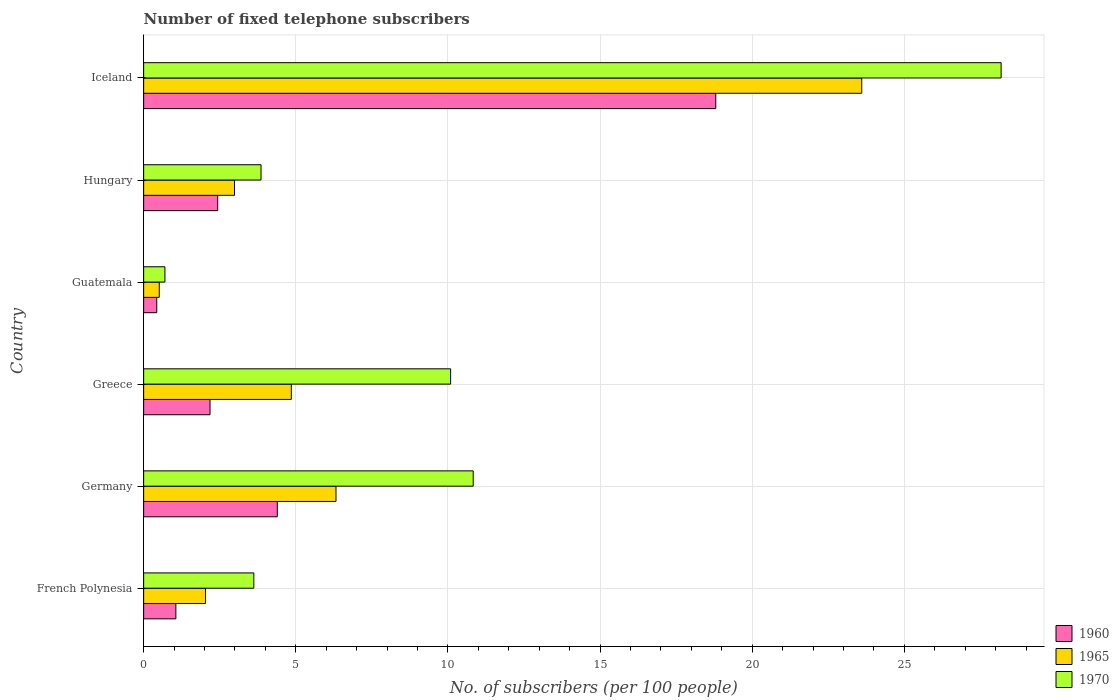Are the number of bars per tick equal to the number of legend labels?
Your answer should be very brief. Yes. Are the number of bars on each tick of the Y-axis equal?
Keep it short and to the point. Yes. What is the label of the 2nd group of bars from the top?
Your answer should be compact. Hungary. What is the number of fixed telephone subscribers in 1965 in Germany?
Your answer should be very brief. 6.32. Across all countries, what is the maximum number of fixed telephone subscribers in 1970?
Your answer should be compact. 28.18. Across all countries, what is the minimum number of fixed telephone subscribers in 1960?
Your response must be concise. 0.43. In which country was the number of fixed telephone subscribers in 1965 maximum?
Provide a succinct answer. Iceland. In which country was the number of fixed telephone subscribers in 1970 minimum?
Your response must be concise. Guatemala. What is the total number of fixed telephone subscribers in 1960 in the graph?
Ensure brevity in your answer.  29.3. What is the difference between the number of fixed telephone subscribers in 1960 in Germany and that in Iceland?
Provide a short and direct response. -14.41. What is the difference between the number of fixed telephone subscribers in 1970 in Greece and the number of fixed telephone subscribers in 1965 in Hungary?
Offer a terse response. 7.1. What is the average number of fixed telephone subscribers in 1960 per country?
Provide a short and direct response. 4.88. What is the difference between the number of fixed telephone subscribers in 1970 and number of fixed telephone subscribers in 1960 in Germany?
Offer a terse response. 6.44. In how many countries, is the number of fixed telephone subscribers in 1965 greater than 6 ?
Provide a succinct answer. 2. What is the ratio of the number of fixed telephone subscribers in 1970 in Greece to that in Hungary?
Your answer should be very brief. 2.62. What is the difference between the highest and the second highest number of fixed telephone subscribers in 1960?
Provide a short and direct response. 14.41. What is the difference between the highest and the lowest number of fixed telephone subscribers in 1970?
Make the answer very short. 27.48. In how many countries, is the number of fixed telephone subscribers in 1960 greater than the average number of fixed telephone subscribers in 1960 taken over all countries?
Offer a very short reply. 1. Is the sum of the number of fixed telephone subscribers in 1965 in Greece and Guatemala greater than the maximum number of fixed telephone subscribers in 1960 across all countries?
Your response must be concise. No. What does the 2nd bar from the bottom in Hungary represents?
Offer a very short reply. 1965. How many bars are there?
Provide a short and direct response. 18. Are all the bars in the graph horizontal?
Ensure brevity in your answer.  Yes. How many countries are there in the graph?
Ensure brevity in your answer.  6. Are the values on the major ticks of X-axis written in scientific E-notation?
Your answer should be very brief. No. Where does the legend appear in the graph?
Provide a short and direct response. Bottom right. How many legend labels are there?
Your answer should be very brief. 3. How are the legend labels stacked?
Your response must be concise. Vertical. What is the title of the graph?
Offer a very short reply. Number of fixed telephone subscribers. What is the label or title of the X-axis?
Your answer should be very brief. No. of subscribers (per 100 people). What is the No. of subscribers (per 100 people) of 1960 in French Polynesia?
Your answer should be very brief. 1.06. What is the No. of subscribers (per 100 people) of 1965 in French Polynesia?
Ensure brevity in your answer.  2.03. What is the No. of subscribers (per 100 people) in 1970 in French Polynesia?
Ensure brevity in your answer.  3.62. What is the No. of subscribers (per 100 people) in 1960 in Germany?
Make the answer very short. 4.39. What is the No. of subscribers (per 100 people) in 1965 in Germany?
Your response must be concise. 6.32. What is the No. of subscribers (per 100 people) of 1970 in Germany?
Make the answer very short. 10.83. What is the No. of subscribers (per 100 people) in 1960 in Greece?
Offer a very short reply. 2.18. What is the No. of subscribers (per 100 people) in 1965 in Greece?
Provide a succinct answer. 4.85. What is the No. of subscribers (per 100 people) of 1970 in Greece?
Offer a terse response. 10.09. What is the No. of subscribers (per 100 people) of 1960 in Guatemala?
Your response must be concise. 0.43. What is the No. of subscribers (per 100 people) in 1965 in Guatemala?
Keep it short and to the point. 0.51. What is the No. of subscribers (per 100 people) in 1970 in Guatemala?
Keep it short and to the point. 0.7. What is the No. of subscribers (per 100 people) in 1960 in Hungary?
Ensure brevity in your answer.  2.43. What is the No. of subscribers (per 100 people) of 1965 in Hungary?
Give a very brief answer. 2.99. What is the No. of subscribers (per 100 people) in 1970 in Hungary?
Keep it short and to the point. 3.86. What is the No. of subscribers (per 100 people) in 1960 in Iceland?
Provide a short and direct response. 18.8. What is the No. of subscribers (per 100 people) of 1965 in Iceland?
Your answer should be very brief. 23.6. What is the No. of subscribers (per 100 people) in 1970 in Iceland?
Offer a terse response. 28.18. Across all countries, what is the maximum No. of subscribers (per 100 people) of 1960?
Provide a short and direct response. 18.8. Across all countries, what is the maximum No. of subscribers (per 100 people) of 1965?
Provide a succinct answer. 23.6. Across all countries, what is the maximum No. of subscribers (per 100 people) in 1970?
Keep it short and to the point. 28.18. Across all countries, what is the minimum No. of subscribers (per 100 people) in 1960?
Give a very brief answer. 0.43. Across all countries, what is the minimum No. of subscribers (per 100 people) of 1965?
Provide a succinct answer. 0.51. Across all countries, what is the minimum No. of subscribers (per 100 people) in 1970?
Provide a succinct answer. 0.7. What is the total No. of subscribers (per 100 people) in 1960 in the graph?
Give a very brief answer. 29.3. What is the total No. of subscribers (per 100 people) in 1965 in the graph?
Your response must be concise. 40.3. What is the total No. of subscribers (per 100 people) of 1970 in the graph?
Provide a short and direct response. 57.27. What is the difference between the No. of subscribers (per 100 people) of 1960 in French Polynesia and that in Germany?
Ensure brevity in your answer.  -3.33. What is the difference between the No. of subscribers (per 100 people) of 1965 in French Polynesia and that in Germany?
Your answer should be very brief. -4.29. What is the difference between the No. of subscribers (per 100 people) of 1970 in French Polynesia and that in Germany?
Offer a very short reply. -7.21. What is the difference between the No. of subscribers (per 100 people) in 1960 in French Polynesia and that in Greece?
Your answer should be very brief. -1.12. What is the difference between the No. of subscribers (per 100 people) of 1965 in French Polynesia and that in Greece?
Offer a very short reply. -2.82. What is the difference between the No. of subscribers (per 100 people) of 1970 in French Polynesia and that in Greece?
Your answer should be very brief. -6.47. What is the difference between the No. of subscribers (per 100 people) in 1960 in French Polynesia and that in Guatemala?
Keep it short and to the point. 0.63. What is the difference between the No. of subscribers (per 100 people) in 1965 in French Polynesia and that in Guatemala?
Offer a very short reply. 1.52. What is the difference between the No. of subscribers (per 100 people) in 1970 in French Polynesia and that in Guatemala?
Ensure brevity in your answer.  2.92. What is the difference between the No. of subscribers (per 100 people) in 1960 in French Polynesia and that in Hungary?
Ensure brevity in your answer.  -1.37. What is the difference between the No. of subscribers (per 100 people) in 1965 in French Polynesia and that in Hungary?
Provide a succinct answer. -0.95. What is the difference between the No. of subscribers (per 100 people) of 1970 in French Polynesia and that in Hungary?
Offer a very short reply. -0.24. What is the difference between the No. of subscribers (per 100 people) of 1960 in French Polynesia and that in Iceland?
Offer a very short reply. -17.74. What is the difference between the No. of subscribers (per 100 people) of 1965 in French Polynesia and that in Iceland?
Offer a terse response. -21.56. What is the difference between the No. of subscribers (per 100 people) in 1970 in French Polynesia and that in Iceland?
Your answer should be very brief. -24.56. What is the difference between the No. of subscribers (per 100 people) of 1960 in Germany and that in Greece?
Ensure brevity in your answer.  2.21. What is the difference between the No. of subscribers (per 100 people) of 1965 in Germany and that in Greece?
Give a very brief answer. 1.47. What is the difference between the No. of subscribers (per 100 people) in 1970 in Germany and that in Greece?
Keep it short and to the point. 0.74. What is the difference between the No. of subscribers (per 100 people) of 1960 in Germany and that in Guatemala?
Make the answer very short. 3.96. What is the difference between the No. of subscribers (per 100 people) of 1965 in Germany and that in Guatemala?
Offer a very short reply. 5.81. What is the difference between the No. of subscribers (per 100 people) in 1970 in Germany and that in Guatemala?
Ensure brevity in your answer.  10.13. What is the difference between the No. of subscribers (per 100 people) of 1960 in Germany and that in Hungary?
Offer a very short reply. 1.96. What is the difference between the No. of subscribers (per 100 people) in 1965 in Germany and that in Hungary?
Your answer should be very brief. 3.33. What is the difference between the No. of subscribers (per 100 people) of 1970 in Germany and that in Hungary?
Provide a succinct answer. 6.97. What is the difference between the No. of subscribers (per 100 people) of 1960 in Germany and that in Iceland?
Ensure brevity in your answer.  -14.41. What is the difference between the No. of subscribers (per 100 people) of 1965 in Germany and that in Iceland?
Provide a succinct answer. -17.28. What is the difference between the No. of subscribers (per 100 people) in 1970 in Germany and that in Iceland?
Your answer should be very brief. -17.35. What is the difference between the No. of subscribers (per 100 people) of 1960 in Greece and that in Guatemala?
Offer a very short reply. 1.75. What is the difference between the No. of subscribers (per 100 people) in 1965 in Greece and that in Guatemala?
Give a very brief answer. 4.34. What is the difference between the No. of subscribers (per 100 people) in 1970 in Greece and that in Guatemala?
Make the answer very short. 9.39. What is the difference between the No. of subscribers (per 100 people) in 1960 in Greece and that in Hungary?
Offer a very short reply. -0.25. What is the difference between the No. of subscribers (per 100 people) in 1965 in Greece and that in Hungary?
Your answer should be very brief. 1.87. What is the difference between the No. of subscribers (per 100 people) of 1970 in Greece and that in Hungary?
Provide a short and direct response. 6.23. What is the difference between the No. of subscribers (per 100 people) of 1960 in Greece and that in Iceland?
Provide a succinct answer. -16.62. What is the difference between the No. of subscribers (per 100 people) of 1965 in Greece and that in Iceland?
Make the answer very short. -18.74. What is the difference between the No. of subscribers (per 100 people) in 1970 in Greece and that in Iceland?
Give a very brief answer. -18.09. What is the difference between the No. of subscribers (per 100 people) of 1960 in Guatemala and that in Hungary?
Make the answer very short. -2. What is the difference between the No. of subscribers (per 100 people) of 1965 in Guatemala and that in Hungary?
Your response must be concise. -2.47. What is the difference between the No. of subscribers (per 100 people) of 1970 in Guatemala and that in Hungary?
Offer a very short reply. -3.16. What is the difference between the No. of subscribers (per 100 people) of 1960 in Guatemala and that in Iceland?
Your answer should be compact. -18.37. What is the difference between the No. of subscribers (per 100 people) of 1965 in Guatemala and that in Iceland?
Keep it short and to the point. -23.08. What is the difference between the No. of subscribers (per 100 people) in 1970 in Guatemala and that in Iceland?
Your answer should be very brief. -27.48. What is the difference between the No. of subscribers (per 100 people) in 1960 in Hungary and that in Iceland?
Your response must be concise. -16.37. What is the difference between the No. of subscribers (per 100 people) of 1965 in Hungary and that in Iceland?
Provide a succinct answer. -20.61. What is the difference between the No. of subscribers (per 100 people) of 1970 in Hungary and that in Iceland?
Provide a succinct answer. -24.32. What is the difference between the No. of subscribers (per 100 people) of 1960 in French Polynesia and the No. of subscribers (per 100 people) of 1965 in Germany?
Your answer should be compact. -5.26. What is the difference between the No. of subscribers (per 100 people) in 1960 in French Polynesia and the No. of subscribers (per 100 people) in 1970 in Germany?
Your response must be concise. -9.77. What is the difference between the No. of subscribers (per 100 people) in 1965 in French Polynesia and the No. of subscribers (per 100 people) in 1970 in Germany?
Your response must be concise. -8.8. What is the difference between the No. of subscribers (per 100 people) of 1960 in French Polynesia and the No. of subscribers (per 100 people) of 1965 in Greece?
Provide a succinct answer. -3.79. What is the difference between the No. of subscribers (per 100 people) in 1960 in French Polynesia and the No. of subscribers (per 100 people) in 1970 in Greece?
Offer a terse response. -9.03. What is the difference between the No. of subscribers (per 100 people) of 1965 in French Polynesia and the No. of subscribers (per 100 people) of 1970 in Greece?
Offer a terse response. -8.05. What is the difference between the No. of subscribers (per 100 people) of 1960 in French Polynesia and the No. of subscribers (per 100 people) of 1965 in Guatemala?
Your response must be concise. 0.55. What is the difference between the No. of subscribers (per 100 people) of 1960 in French Polynesia and the No. of subscribers (per 100 people) of 1970 in Guatemala?
Give a very brief answer. 0.36. What is the difference between the No. of subscribers (per 100 people) of 1965 in French Polynesia and the No. of subscribers (per 100 people) of 1970 in Guatemala?
Provide a short and direct response. 1.33. What is the difference between the No. of subscribers (per 100 people) in 1960 in French Polynesia and the No. of subscribers (per 100 people) in 1965 in Hungary?
Your answer should be compact. -1.93. What is the difference between the No. of subscribers (per 100 people) of 1960 in French Polynesia and the No. of subscribers (per 100 people) of 1970 in Hungary?
Provide a short and direct response. -2.8. What is the difference between the No. of subscribers (per 100 people) in 1965 in French Polynesia and the No. of subscribers (per 100 people) in 1970 in Hungary?
Ensure brevity in your answer.  -1.82. What is the difference between the No. of subscribers (per 100 people) of 1960 in French Polynesia and the No. of subscribers (per 100 people) of 1965 in Iceland?
Make the answer very short. -22.54. What is the difference between the No. of subscribers (per 100 people) in 1960 in French Polynesia and the No. of subscribers (per 100 people) in 1970 in Iceland?
Your response must be concise. -27.12. What is the difference between the No. of subscribers (per 100 people) in 1965 in French Polynesia and the No. of subscribers (per 100 people) in 1970 in Iceland?
Keep it short and to the point. -26.14. What is the difference between the No. of subscribers (per 100 people) of 1960 in Germany and the No. of subscribers (per 100 people) of 1965 in Greece?
Your answer should be compact. -0.46. What is the difference between the No. of subscribers (per 100 people) in 1960 in Germany and the No. of subscribers (per 100 people) in 1970 in Greece?
Offer a very short reply. -5.7. What is the difference between the No. of subscribers (per 100 people) of 1965 in Germany and the No. of subscribers (per 100 people) of 1970 in Greece?
Make the answer very short. -3.77. What is the difference between the No. of subscribers (per 100 people) in 1960 in Germany and the No. of subscribers (per 100 people) in 1965 in Guatemala?
Provide a succinct answer. 3.88. What is the difference between the No. of subscribers (per 100 people) of 1960 in Germany and the No. of subscribers (per 100 people) of 1970 in Guatemala?
Provide a succinct answer. 3.69. What is the difference between the No. of subscribers (per 100 people) of 1965 in Germany and the No. of subscribers (per 100 people) of 1970 in Guatemala?
Your answer should be compact. 5.62. What is the difference between the No. of subscribers (per 100 people) of 1960 in Germany and the No. of subscribers (per 100 people) of 1965 in Hungary?
Keep it short and to the point. 1.41. What is the difference between the No. of subscribers (per 100 people) of 1960 in Germany and the No. of subscribers (per 100 people) of 1970 in Hungary?
Keep it short and to the point. 0.53. What is the difference between the No. of subscribers (per 100 people) in 1965 in Germany and the No. of subscribers (per 100 people) in 1970 in Hungary?
Make the answer very short. 2.46. What is the difference between the No. of subscribers (per 100 people) in 1960 in Germany and the No. of subscribers (per 100 people) in 1965 in Iceland?
Your response must be concise. -19.21. What is the difference between the No. of subscribers (per 100 people) in 1960 in Germany and the No. of subscribers (per 100 people) in 1970 in Iceland?
Give a very brief answer. -23.79. What is the difference between the No. of subscribers (per 100 people) of 1965 in Germany and the No. of subscribers (per 100 people) of 1970 in Iceland?
Give a very brief answer. -21.86. What is the difference between the No. of subscribers (per 100 people) of 1960 in Greece and the No. of subscribers (per 100 people) of 1965 in Guatemala?
Keep it short and to the point. 1.67. What is the difference between the No. of subscribers (per 100 people) in 1960 in Greece and the No. of subscribers (per 100 people) in 1970 in Guatemala?
Your answer should be very brief. 1.48. What is the difference between the No. of subscribers (per 100 people) of 1965 in Greece and the No. of subscribers (per 100 people) of 1970 in Guatemala?
Provide a succinct answer. 4.15. What is the difference between the No. of subscribers (per 100 people) of 1960 in Greece and the No. of subscribers (per 100 people) of 1965 in Hungary?
Provide a short and direct response. -0.81. What is the difference between the No. of subscribers (per 100 people) of 1960 in Greece and the No. of subscribers (per 100 people) of 1970 in Hungary?
Your answer should be compact. -1.68. What is the difference between the No. of subscribers (per 100 people) in 1960 in Greece and the No. of subscribers (per 100 people) in 1965 in Iceland?
Give a very brief answer. -21.42. What is the difference between the No. of subscribers (per 100 people) of 1960 in Greece and the No. of subscribers (per 100 people) of 1970 in Iceland?
Your answer should be compact. -26. What is the difference between the No. of subscribers (per 100 people) in 1965 in Greece and the No. of subscribers (per 100 people) in 1970 in Iceland?
Give a very brief answer. -23.32. What is the difference between the No. of subscribers (per 100 people) in 1960 in Guatemala and the No. of subscribers (per 100 people) in 1965 in Hungary?
Keep it short and to the point. -2.56. What is the difference between the No. of subscribers (per 100 people) of 1960 in Guatemala and the No. of subscribers (per 100 people) of 1970 in Hungary?
Provide a succinct answer. -3.43. What is the difference between the No. of subscribers (per 100 people) in 1965 in Guatemala and the No. of subscribers (per 100 people) in 1970 in Hungary?
Provide a short and direct response. -3.34. What is the difference between the No. of subscribers (per 100 people) in 1960 in Guatemala and the No. of subscribers (per 100 people) in 1965 in Iceland?
Your answer should be very brief. -23.17. What is the difference between the No. of subscribers (per 100 people) of 1960 in Guatemala and the No. of subscribers (per 100 people) of 1970 in Iceland?
Your answer should be very brief. -27.75. What is the difference between the No. of subscribers (per 100 people) in 1965 in Guatemala and the No. of subscribers (per 100 people) in 1970 in Iceland?
Your answer should be very brief. -27.66. What is the difference between the No. of subscribers (per 100 people) of 1960 in Hungary and the No. of subscribers (per 100 people) of 1965 in Iceland?
Offer a very short reply. -21.16. What is the difference between the No. of subscribers (per 100 people) of 1960 in Hungary and the No. of subscribers (per 100 people) of 1970 in Iceland?
Offer a terse response. -25.74. What is the difference between the No. of subscribers (per 100 people) of 1965 in Hungary and the No. of subscribers (per 100 people) of 1970 in Iceland?
Give a very brief answer. -25.19. What is the average No. of subscribers (per 100 people) in 1960 per country?
Your answer should be compact. 4.88. What is the average No. of subscribers (per 100 people) in 1965 per country?
Offer a very short reply. 6.72. What is the average No. of subscribers (per 100 people) of 1970 per country?
Make the answer very short. 9.55. What is the difference between the No. of subscribers (per 100 people) of 1960 and No. of subscribers (per 100 people) of 1965 in French Polynesia?
Ensure brevity in your answer.  -0.97. What is the difference between the No. of subscribers (per 100 people) in 1960 and No. of subscribers (per 100 people) in 1970 in French Polynesia?
Provide a short and direct response. -2.56. What is the difference between the No. of subscribers (per 100 people) in 1965 and No. of subscribers (per 100 people) in 1970 in French Polynesia?
Provide a short and direct response. -1.59. What is the difference between the No. of subscribers (per 100 people) of 1960 and No. of subscribers (per 100 people) of 1965 in Germany?
Ensure brevity in your answer.  -1.93. What is the difference between the No. of subscribers (per 100 people) in 1960 and No. of subscribers (per 100 people) in 1970 in Germany?
Make the answer very short. -6.44. What is the difference between the No. of subscribers (per 100 people) in 1965 and No. of subscribers (per 100 people) in 1970 in Germany?
Keep it short and to the point. -4.51. What is the difference between the No. of subscribers (per 100 people) of 1960 and No. of subscribers (per 100 people) of 1965 in Greece?
Your answer should be very brief. -2.67. What is the difference between the No. of subscribers (per 100 people) of 1960 and No. of subscribers (per 100 people) of 1970 in Greece?
Provide a succinct answer. -7.91. What is the difference between the No. of subscribers (per 100 people) in 1965 and No. of subscribers (per 100 people) in 1970 in Greece?
Your answer should be very brief. -5.23. What is the difference between the No. of subscribers (per 100 people) of 1960 and No. of subscribers (per 100 people) of 1965 in Guatemala?
Provide a succinct answer. -0.08. What is the difference between the No. of subscribers (per 100 people) of 1960 and No. of subscribers (per 100 people) of 1970 in Guatemala?
Keep it short and to the point. -0.27. What is the difference between the No. of subscribers (per 100 people) in 1965 and No. of subscribers (per 100 people) in 1970 in Guatemala?
Provide a short and direct response. -0.19. What is the difference between the No. of subscribers (per 100 people) in 1960 and No. of subscribers (per 100 people) in 1965 in Hungary?
Ensure brevity in your answer.  -0.55. What is the difference between the No. of subscribers (per 100 people) of 1960 and No. of subscribers (per 100 people) of 1970 in Hungary?
Offer a very short reply. -1.42. What is the difference between the No. of subscribers (per 100 people) in 1965 and No. of subscribers (per 100 people) in 1970 in Hungary?
Your answer should be compact. -0.87. What is the difference between the No. of subscribers (per 100 people) in 1960 and No. of subscribers (per 100 people) in 1965 in Iceland?
Your response must be concise. -4.8. What is the difference between the No. of subscribers (per 100 people) in 1960 and No. of subscribers (per 100 people) in 1970 in Iceland?
Ensure brevity in your answer.  -9.38. What is the difference between the No. of subscribers (per 100 people) of 1965 and No. of subscribers (per 100 people) of 1970 in Iceland?
Offer a terse response. -4.58. What is the ratio of the No. of subscribers (per 100 people) in 1960 in French Polynesia to that in Germany?
Keep it short and to the point. 0.24. What is the ratio of the No. of subscribers (per 100 people) in 1965 in French Polynesia to that in Germany?
Keep it short and to the point. 0.32. What is the ratio of the No. of subscribers (per 100 people) in 1970 in French Polynesia to that in Germany?
Your answer should be compact. 0.33. What is the ratio of the No. of subscribers (per 100 people) in 1960 in French Polynesia to that in Greece?
Offer a very short reply. 0.49. What is the ratio of the No. of subscribers (per 100 people) of 1965 in French Polynesia to that in Greece?
Your response must be concise. 0.42. What is the ratio of the No. of subscribers (per 100 people) in 1970 in French Polynesia to that in Greece?
Your answer should be very brief. 0.36. What is the ratio of the No. of subscribers (per 100 people) in 1960 in French Polynesia to that in Guatemala?
Make the answer very short. 2.46. What is the ratio of the No. of subscribers (per 100 people) in 1965 in French Polynesia to that in Guatemala?
Provide a short and direct response. 3.96. What is the ratio of the No. of subscribers (per 100 people) of 1970 in French Polynesia to that in Guatemala?
Provide a short and direct response. 5.18. What is the ratio of the No. of subscribers (per 100 people) in 1960 in French Polynesia to that in Hungary?
Offer a very short reply. 0.44. What is the ratio of the No. of subscribers (per 100 people) in 1965 in French Polynesia to that in Hungary?
Offer a very short reply. 0.68. What is the ratio of the No. of subscribers (per 100 people) of 1970 in French Polynesia to that in Hungary?
Your answer should be very brief. 0.94. What is the ratio of the No. of subscribers (per 100 people) of 1960 in French Polynesia to that in Iceland?
Provide a short and direct response. 0.06. What is the ratio of the No. of subscribers (per 100 people) of 1965 in French Polynesia to that in Iceland?
Provide a short and direct response. 0.09. What is the ratio of the No. of subscribers (per 100 people) of 1970 in French Polynesia to that in Iceland?
Make the answer very short. 0.13. What is the ratio of the No. of subscribers (per 100 people) of 1960 in Germany to that in Greece?
Your answer should be compact. 2.01. What is the ratio of the No. of subscribers (per 100 people) of 1965 in Germany to that in Greece?
Offer a terse response. 1.3. What is the ratio of the No. of subscribers (per 100 people) in 1970 in Germany to that in Greece?
Offer a terse response. 1.07. What is the ratio of the No. of subscribers (per 100 people) in 1960 in Germany to that in Guatemala?
Offer a very short reply. 10.2. What is the ratio of the No. of subscribers (per 100 people) of 1965 in Germany to that in Guatemala?
Provide a short and direct response. 12.32. What is the ratio of the No. of subscribers (per 100 people) of 1970 in Germany to that in Guatemala?
Make the answer very short. 15.49. What is the ratio of the No. of subscribers (per 100 people) of 1960 in Germany to that in Hungary?
Provide a succinct answer. 1.8. What is the ratio of the No. of subscribers (per 100 people) of 1965 in Germany to that in Hungary?
Make the answer very short. 2.12. What is the ratio of the No. of subscribers (per 100 people) in 1970 in Germany to that in Hungary?
Keep it short and to the point. 2.81. What is the ratio of the No. of subscribers (per 100 people) of 1960 in Germany to that in Iceland?
Provide a succinct answer. 0.23. What is the ratio of the No. of subscribers (per 100 people) of 1965 in Germany to that in Iceland?
Give a very brief answer. 0.27. What is the ratio of the No. of subscribers (per 100 people) in 1970 in Germany to that in Iceland?
Ensure brevity in your answer.  0.38. What is the ratio of the No. of subscribers (per 100 people) of 1960 in Greece to that in Guatemala?
Give a very brief answer. 5.07. What is the ratio of the No. of subscribers (per 100 people) in 1965 in Greece to that in Guatemala?
Offer a terse response. 9.46. What is the ratio of the No. of subscribers (per 100 people) in 1970 in Greece to that in Guatemala?
Offer a very short reply. 14.43. What is the ratio of the No. of subscribers (per 100 people) in 1960 in Greece to that in Hungary?
Give a very brief answer. 0.9. What is the ratio of the No. of subscribers (per 100 people) of 1965 in Greece to that in Hungary?
Provide a succinct answer. 1.62. What is the ratio of the No. of subscribers (per 100 people) in 1970 in Greece to that in Hungary?
Your answer should be compact. 2.62. What is the ratio of the No. of subscribers (per 100 people) of 1960 in Greece to that in Iceland?
Provide a short and direct response. 0.12. What is the ratio of the No. of subscribers (per 100 people) in 1965 in Greece to that in Iceland?
Provide a short and direct response. 0.21. What is the ratio of the No. of subscribers (per 100 people) of 1970 in Greece to that in Iceland?
Offer a very short reply. 0.36. What is the ratio of the No. of subscribers (per 100 people) in 1960 in Guatemala to that in Hungary?
Give a very brief answer. 0.18. What is the ratio of the No. of subscribers (per 100 people) of 1965 in Guatemala to that in Hungary?
Ensure brevity in your answer.  0.17. What is the ratio of the No. of subscribers (per 100 people) in 1970 in Guatemala to that in Hungary?
Provide a short and direct response. 0.18. What is the ratio of the No. of subscribers (per 100 people) in 1960 in Guatemala to that in Iceland?
Offer a terse response. 0.02. What is the ratio of the No. of subscribers (per 100 people) in 1965 in Guatemala to that in Iceland?
Make the answer very short. 0.02. What is the ratio of the No. of subscribers (per 100 people) of 1970 in Guatemala to that in Iceland?
Offer a terse response. 0.02. What is the ratio of the No. of subscribers (per 100 people) in 1960 in Hungary to that in Iceland?
Offer a very short reply. 0.13. What is the ratio of the No. of subscribers (per 100 people) of 1965 in Hungary to that in Iceland?
Your answer should be compact. 0.13. What is the ratio of the No. of subscribers (per 100 people) in 1970 in Hungary to that in Iceland?
Your answer should be compact. 0.14. What is the difference between the highest and the second highest No. of subscribers (per 100 people) in 1960?
Give a very brief answer. 14.41. What is the difference between the highest and the second highest No. of subscribers (per 100 people) of 1965?
Make the answer very short. 17.28. What is the difference between the highest and the second highest No. of subscribers (per 100 people) in 1970?
Provide a succinct answer. 17.35. What is the difference between the highest and the lowest No. of subscribers (per 100 people) of 1960?
Provide a short and direct response. 18.37. What is the difference between the highest and the lowest No. of subscribers (per 100 people) of 1965?
Ensure brevity in your answer.  23.08. What is the difference between the highest and the lowest No. of subscribers (per 100 people) of 1970?
Make the answer very short. 27.48. 